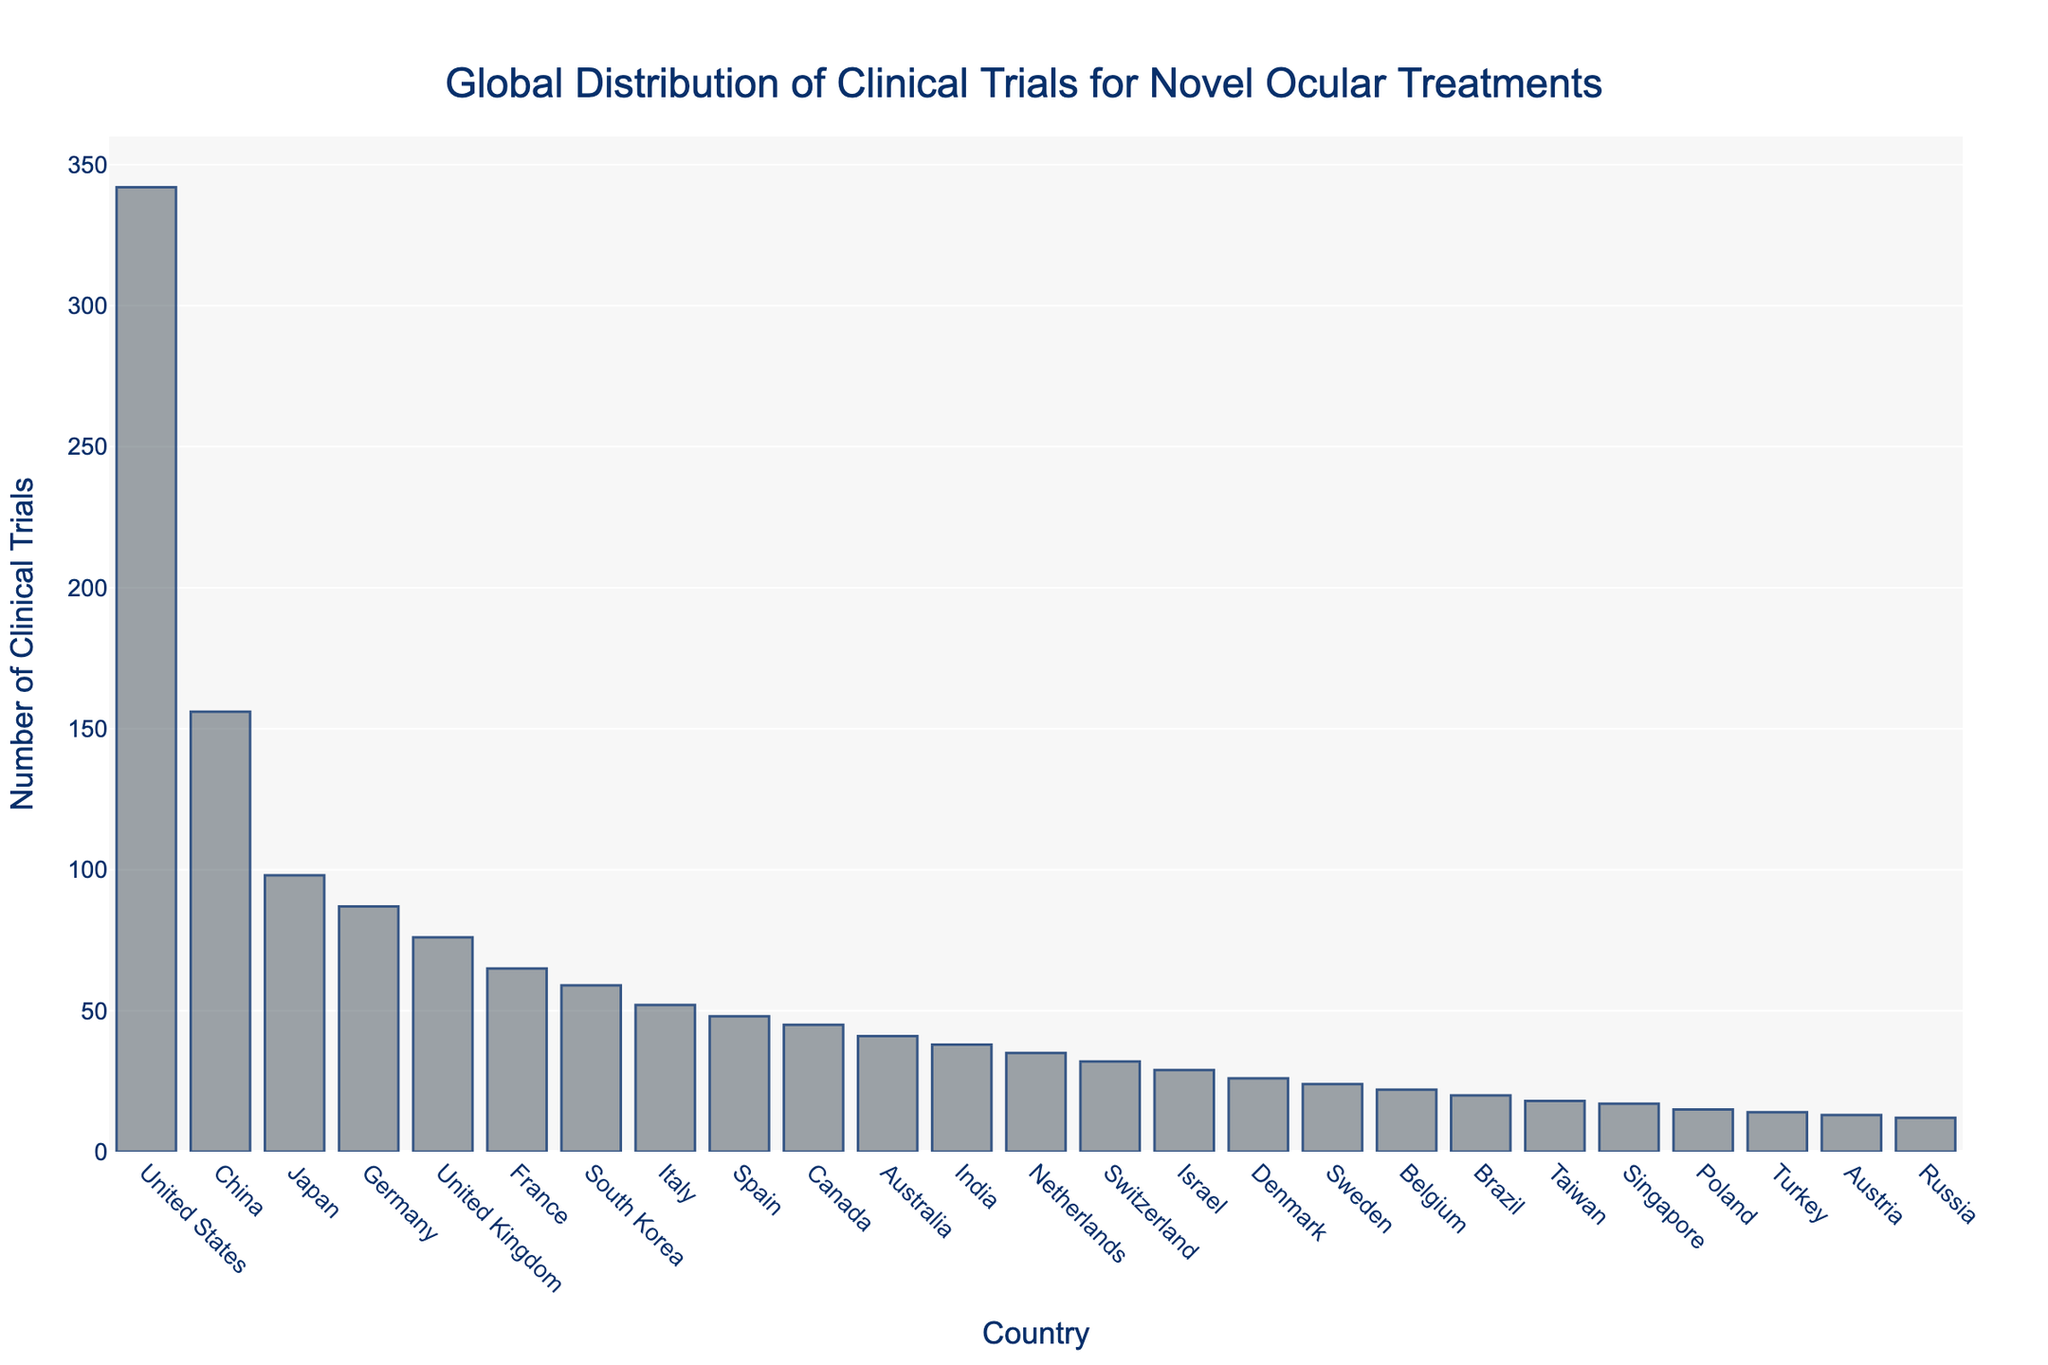Which country has the highest number of clinical trials? The United States is at the top of the bar chart with the highest bar, indicating it has the highest number of clinical trials.
Answer: United States Which countries have less than 50 clinical trials? From the bar chart, the countries with bars shorter than the mark for 50 clinical trials are Spain, Canada, Australia, India, Netherlands, Switzerland, Israel, Denmark, Sweden, Belgium, Brazil, Taiwan, Singapore, Poland, Turkey, Austria, and Russia.
Answer: Spain, Canada, Australia, India, Netherlands, Switzerland, Israel, Denmark, Sweden, Belgium, Brazil, Taiwan, Singapore, Poland, Turkey, Austria, Russia How many more clinical trials are conducted in the United States compared to China? The United States has 342 clinical trials and China has 156. Subtracting China's count from the United States' count gives 342 - 156 = 186.
Answer: 186 What is the total number of clinical trials conducted in Japan, Germany, and the United Kingdom combined? Adding the number of clinical trials for Japan (98), Germany (87), and the United Kingdom (76) gives 98 + 87 + 76 = 261.
Answer: 261 Which two countries have the closest numbers of clinical trials, and what are those numbers? Switzerland and Israel have bars that are very close in height. Switzerland has 32 clinical trials, and Israel has 29, making them the closest in count.
Answer: Switzerland: 32, Israel: 29 Are there more clinical trials in South Korea or Canada? The bar for South Korea is taller than the bar for Canada, indicating that South Korea, with 59 clinical trials, has more than Canada, which has 45.
Answer: South Korea Is the number of clinical trials in India greater than in the Netherlands? The bar for India is taller than the bar for the Netherlands, indicating that India, with 38 clinical trials, has more than the Netherlands, which has 35.
Answer: Yes How many countries have more than 100 clinical trials? The bars that exceed the 100 mark are for the United States, China, and Japan. Counting these countries results in three countries.
Answer: 3 What is the approximate difference between the number of clinical trials in Germany and France? The number of clinical trials in Germany is 87, and in France, it is 65. The difference is approximately 87 - 65 = 22.
Answer: 22 